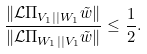<formula> <loc_0><loc_0><loc_500><loc_500>\frac { \| \mathcal { L } \Pi _ { V _ { 1 } | | W _ { 1 } } \tilde { w } \| } { \| \mathcal { L } \Pi _ { W _ { 1 } | | V _ { 1 } } \tilde { w } \| } \leq \frac { 1 } { 2 } .</formula> 